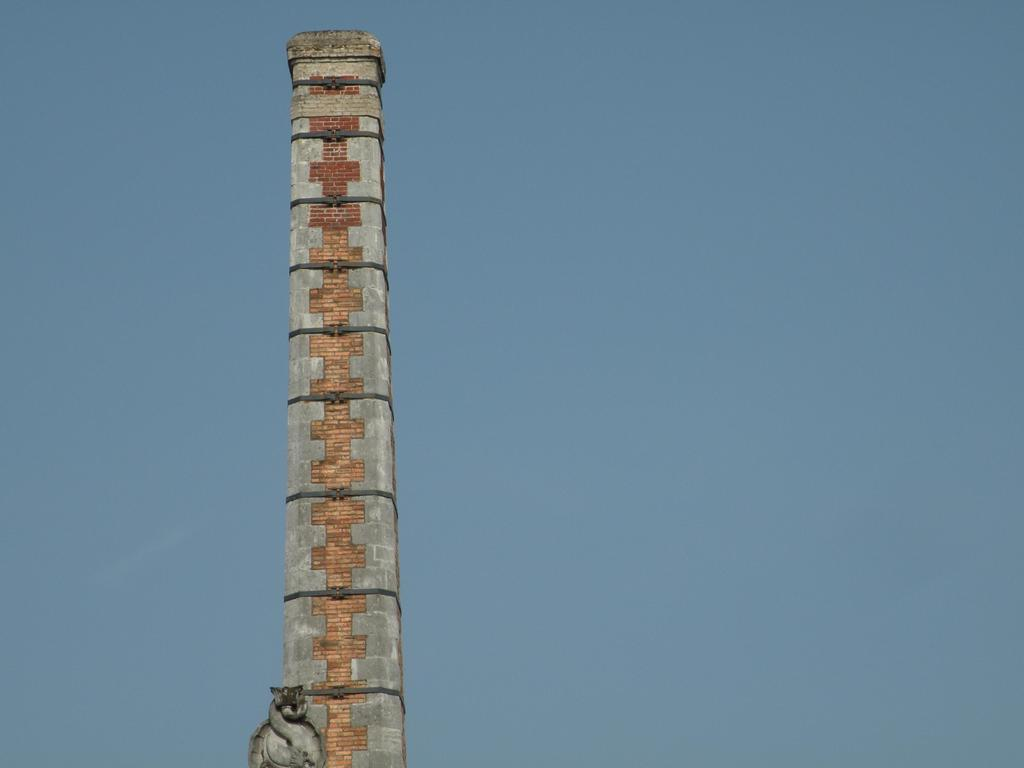What is the main subject of the image? There is a tower in the middle of the image. Can you describe the tower in the image? The tower is the main subject of the image, and it is located in the center. What might be the purpose of the tower in the image? The purpose of the tower in the image is not explicitly stated, but it could be a landmark, a watchtower, or part of a larger structure. Can you tell me how many donkeys are visible in the image? There are no donkeys present in the image; the main subject is a tower. What type of receipt can be seen on the ground near the tower? There is no receipt present in the image; the image only features a tower. 